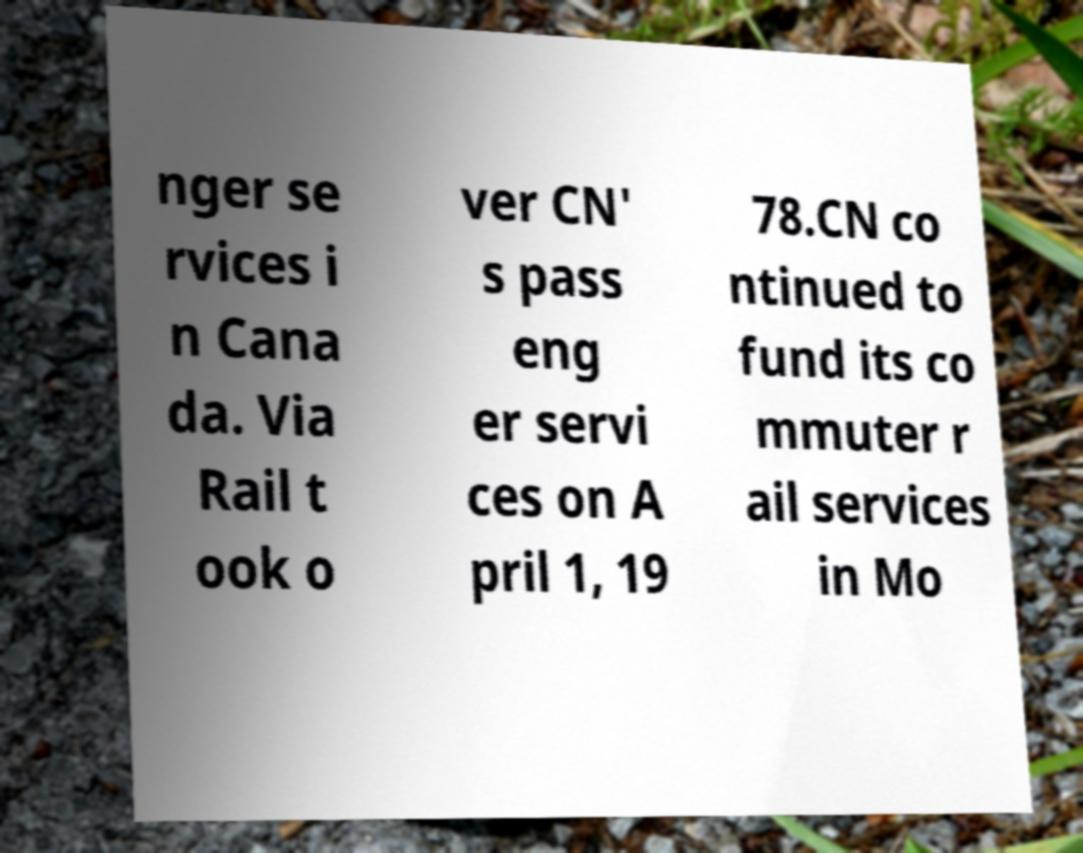Could you assist in decoding the text presented in this image and type it out clearly? nger se rvices i n Cana da. Via Rail t ook o ver CN' s pass eng er servi ces on A pril 1, 19 78.CN co ntinued to fund its co mmuter r ail services in Mo 